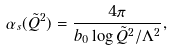Convert formula to latex. <formula><loc_0><loc_0><loc_500><loc_500>\alpha _ { s } ( \tilde { Q } ^ { 2 } ) = \frac { 4 \pi } { b _ { 0 } \log { \tilde { Q } ^ { 2 } / \Lambda ^ { 2 } } } ,</formula> 